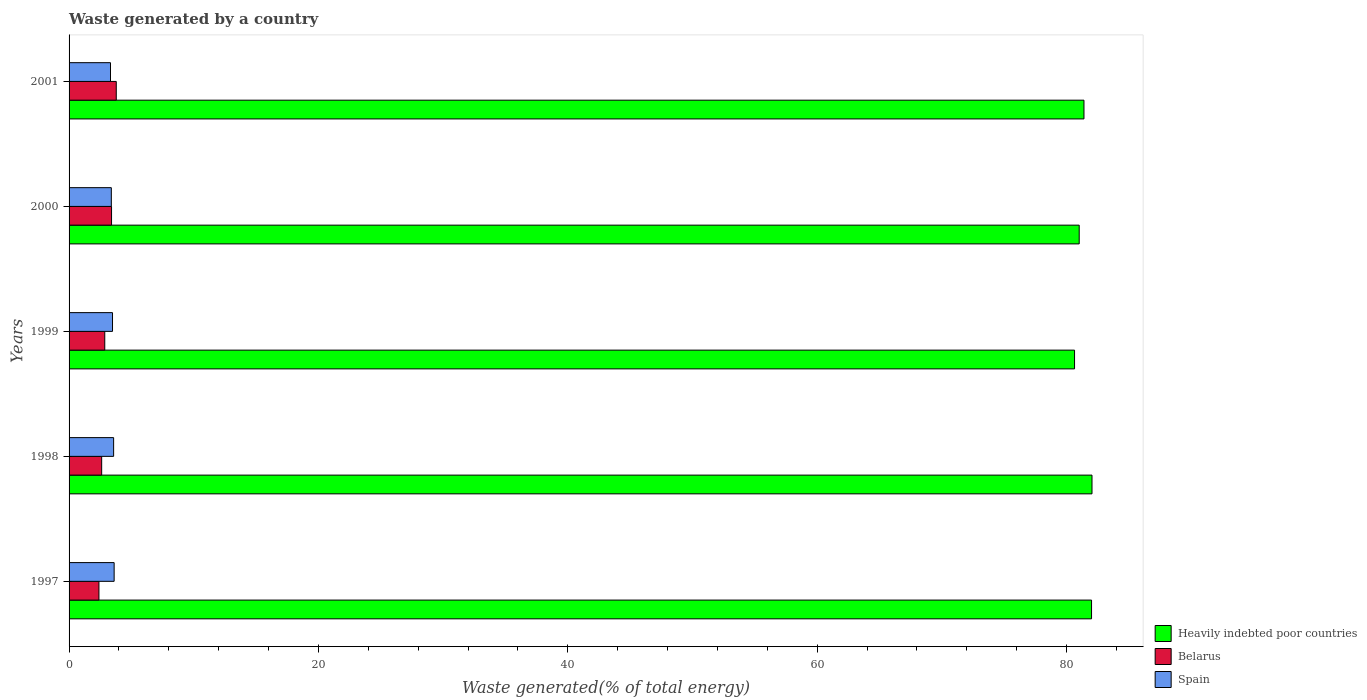How many different coloured bars are there?
Give a very brief answer. 3. Are the number of bars per tick equal to the number of legend labels?
Your answer should be compact. Yes. Are the number of bars on each tick of the Y-axis equal?
Your answer should be compact. Yes. How many bars are there on the 4th tick from the top?
Give a very brief answer. 3. What is the total waste generated in Spain in 1998?
Keep it short and to the point. 3.57. Across all years, what is the maximum total waste generated in Heavily indebted poor countries?
Give a very brief answer. 82.04. Across all years, what is the minimum total waste generated in Heavily indebted poor countries?
Provide a short and direct response. 80.64. In which year was the total waste generated in Belarus maximum?
Offer a terse response. 2001. What is the total total waste generated in Heavily indebted poor countries in the graph?
Offer a terse response. 407.1. What is the difference between the total waste generated in Spain in 1999 and that in 2001?
Keep it short and to the point. 0.16. What is the difference between the total waste generated in Heavily indebted poor countries in 1997 and the total waste generated in Spain in 1999?
Keep it short and to the point. 78.52. What is the average total waste generated in Spain per year?
Provide a short and direct response. 3.48. In the year 1998, what is the difference between the total waste generated in Heavily indebted poor countries and total waste generated in Spain?
Provide a short and direct response. 78.47. In how many years, is the total waste generated in Belarus greater than 32 %?
Offer a very short reply. 0. What is the ratio of the total waste generated in Belarus in 1997 to that in 1998?
Ensure brevity in your answer.  0.92. What is the difference between the highest and the second highest total waste generated in Belarus?
Offer a very short reply. 0.38. What is the difference between the highest and the lowest total waste generated in Belarus?
Provide a succinct answer. 1.39. In how many years, is the total waste generated in Belarus greater than the average total waste generated in Belarus taken over all years?
Provide a short and direct response. 2. What does the 1st bar from the top in 1997 represents?
Provide a succinct answer. Spain. What does the 1st bar from the bottom in 2001 represents?
Make the answer very short. Heavily indebted poor countries. How many bars are there?
Make the answer very short. 15. What is the difference between two consecutive major ticks on the X-axis?
Provide a short and direct response. 20. Does the graph contain any zero values?
Your answer should be very brief. No. How are the legend labels stacked?
Offer a very short reply. Vertical. What is the title of the graph?
Make the answer very short. Waste generated by a country. Does "World" appear as one of the legend labels in the graph?
Offer a very short reply. No. What is the label or title of the X-axis?
Offer a very short reply. Waste generated(% of total energy). What is the Waste generated(% of total energy) of Heavily indebted poor countries in 1997?
Your response must be concise. 82. What is the Waste generated(% of total energy) of Belarus in 1997?
Provide a succinct answer. 2.4. What is the Waste generated(% of total energy) in Spain in 1997?
Provide a succinct answer. 3.62. What is the Waste generated(% of total energy) in Heavily indebted poor countries in 1998?
Offer a very short reply. 82.04. What is the Waste generated(% of total energy) in Belarus in 1998?
Give a very brief answer. 2.61. What is the Waste generated(% of total energy) in Spain in 1998?
Offer a very short reply. 3.57. What is the Waste generated(% of total energy) in Heavily indebted poor countries in 1999?
Your answer should be compact. 80.64. What is the Waste generated(% of total energy) of Belarus in 1999?
Give a very brief answer. 2.86. What is the Waste generated(% of total energy) of Spain in 1999?
Keep it short and to the point. 3.48. What is the Waste generated(% of total energy) of Heavily indebted poor countries in 2000?
Make the answer very short. 81.02. What is the Waste generated(% of total energy) in Belarus in 2000?
Your answer should be very brief. 3.41. What is the Waste generated(% of total energy) of Spain in 2000?
Provide a short and direct response. 3.39. What is the Waste generated(% of total energy) in Heavily indebted poor countries in 2001?
Your answer should be compact. 81.4. What is the Waste generated(% of total energy) of Belarus in 2001?
Give a very brief answer. 3.79. What is the Waste generated(% of total energy) in Spain in 2001?
Your response must be concise. 3.32. Across all years, what is the maximum Waste generated(% of total energy) in Heavily indebted poor countries?
Offer a very short reply. 82.04. Across all years, what is the maximum Waste generated(% of total energy) in Belarus?
Give a very brief answer. 3.79. Across all years, what is the maximum Waste generated(% of total energy) in Spain?
Offer a terse response. 3.62. Across all years, what is the minimum Waste generated(% of total energy) of Heavily indebted poor countries?
Give a very brief answer. 80.64. Across all years, what is the minimum Waste generated(% of total energy) in Belarus?
Offer a terse response. 2.4. Across all years, what is the minimum Waste generated(% of total energy) of Spain?
Provide a short and direct response. 3.32. What is the total Waste generated(% of total energy) of Heavily indebted poor countries in the graph?
Offer a very short reply. 407.1. What is the total Waste generated(% of total energy) in Belarus in the graph?
Offer a terse response. 15.07. What is the total Waste generated(% of total energy) in Spain in the graph?
Make the answer very short. 17.39. What is the difference between the Waste generated(% of total energy) of Heavily indebted poor countries in 1997 and that in 1998?
Give a very brief answer. -0.04. What is the difference between the Waste generated(% of total energy) in Belarus in 1997 and that in 1998?
Keep it short and to the point. -0.22. What is the difference between the Waste generated(% of total energy) in Spain in 1997 and that in 1998?
Your answer should be very brief. 0.04. What is the difference between the Waste generated(% of total energy) in Heavily indebted poor countries in 1997 and that in 1999?
Give a very brief answer. 1.36. What is the difference between the Waste generated(% of total energy) in Belarus in 1997 and that in 1999?
Your answer should be compact. -0.47. What is the difference between the Waste generated(% of total energy) of Spain in 1997 and that in 1999?
Provide a succinct answer. 0.13. What is the difference between the Waste generated(% of total energy) of Heavily indebted poor countries in 1997 and that in 2000?
Your answer should be compact. 0.99. What is the difference between the Waste generated(% of total energy) of Belarus in 1997 and that in 2000?
Offer a very short reply. -1.01. What is the difference between the Waste generated(% of total energy) in Spain in 1997 and that in 2000?
Offer a terse response. 0.23. What is the difference between the Waste generated(% of total energy) of Heavily indebted poor countries in 1997 and that in 2001?
Your response must be concise. 0.61. What is the difference between the Waste generated(% of total energy) in Belarus in 1997 and that in 2001?
Your answer should be very brief. -1.39. What is the difference between the Waste generated(% of total energy) of Spain in 1997 and that in 2001?
Keep it short and to the point. 0.29. What is the difference between the Waste generated(% of total energy) in Heavily indebted poor countries in 1998 and that in 1999?
Give a very brief answer. 1.4. What is the difference between the Waste generated(% of total energy) of Belarus in 1998 and that in 1999?
Ensure brevity in your answer.  -0.25. What is the difference between the Waste generated(% of total energy) of Spain in 1998 and that in 1999?
Give a very brief answer. 0.09. What is the difference between the Waste generated(% of total energy) of Heavily indebted poor countries in 1998 and that in 2000?
Give a very brief answer. 1.03. What is the difference between the Waste generated(% of total energy) of Belarus in 1998 and that in 2000?
Keep it short and to the point. -0.79. What is the difference between the Waste generated(% of total energy) of Spain in 1998 and that in 2000?
Offer a terse response. 0.18. What is the difference between the Waste generated(% of total energy) in Heavily indebted poor countries in 1998 and that in 2001?
Offer a very short reply. 0.64. What is the difference between the Waste generated(% of total energy) of Belarus in 1998 and that in 2001?
Your response must be concise. -1.17. What is the difference between the Waste generated(% of total energy) in Spain in 1998 and that in 2001?
Your answer should be very brief. 0.25. What is the difference between the Waste generated(% of total energy) of Heavily indebted poor countries in 1999 and that in 2000?
Provide a succinct answer. -0.37. What is the difference between the Waste generated(% of total energy) of Belarus in 1999 and that in 2000?
Keep it short and to the point. -0.54. What is the difference between the Waste generated(% of total energy) in Spain in 1999 and that in 2000?
Provide a short and direct response. 0.1. What is the difference between the Waste generated(% of total energy) in Heavily indebted poor countries in 1999 and that in 2001?
Offer a very short reply. -0.76. What is the difference between the Waste generated(% of total energy) in Belarus in 1999 and that in 2001?
Offer a very short reply. -0.92. What is the difference between the Waste generated(% of total energy) of Spain in 1999 and that in 2001?
Make the answer very short. 0.16. What is the difference between the Waste generated(% of total energy) of Heavily indebted poor countries in 2000 and that in 2001?
Keep it short and to the point. -0.38. What is the difference between the Waste generated(% of total energy) in Belarus in 2000 and that in 2001?
Provide a succinct answer. -0.38. What is the difference between the Waste generated(% of total energy) in Spain in 2000 and that in 2001?
Ensure brevity in your answer.  0.07. What is the difference between the Waste generated(% of total energy) of Heavily indebted poor countries in 1997 and the Waste generated(% of total energy) of Belarus in 1998?
Offer a terse response. 79.39. What is the difference between the Waste generated(% of total energy) in Heavily indebted poor countries in 1997 and the Waste generated(% of total energy) in Spain in 1998?
Offer a very short reply. 78.43. What is the difference between the Waste generated(% of total energy) of Belarus in 1997 and the Waste generated(% of total energy) of Spain in 1998?
Give a very brief answer. -1.18. What is the difference between the Waste generated(% of total energy) of Heavily indebted poor countries in 1997 and the Waste generated(% of total energy) of Belarus in 1999?
Provide a succinct answer. 79.14. What is the difference between the Waste generated(% of total energy) in Heavily indebted poor countries in 1997 and the Waste generated(% of total energy) in Spain in 1999?
Provide a succinct answer. 78.52. What is the difference between the Waste generated(% of total energy) of Belarus in 1997 and the Waste generated(% of total energy) of Spain in 1999?
Your response must be concise. -1.09. What is the difference between the Waste generated(% of total energy) of Heavily indebted poor countries in 1997 and the Waste generated(% of total energy) of Belarus in 2000?
Offer a terse response. 78.6. What is the difference between the Waste generated(% of total energy) of Heavily indebted poor countries in 1997 and the Waste generated(% of total energy) of Spain in 2000?
Give a very brief answer. 78.62. What is the difference between the Waste generated(% of total energy) of Belarus in 1997 and the Waste generated(% of total energy) of Spain in 2000?
Provide a short and direct response. -0.99. What is the difference between the Waste generated(% of total energy) of Heavily indebted poor countries in 1997 and the Waste generated(% of total energy) of Belarus in 2001?
Provide a short and direct response. 78.22. What is the difference between the Waste generated(% of total energy) in Heavily indebted poor countries in 1997 and the Waste generated(% of total energy) in Spain in 2001?
Your answer should be very brief. 78.68. What is the difference between the Waste generated(% of total energy) of Belarus in 1997 and the Waste generated(% of total energy) of Spain in 2001?
Your answer should be compact. -0.93. What is the difference between the Waste generated(% of total energy) of Heavily indebted poor countries in 1998 and the Waste generated(% of total energy) of Belarus in 1999?
Your response must be concise. 79.18. What is the difference between the Waste generated(% of total energy) in Heavily indebted poor countries in 1998 and the Waste generated(% of total energy) in Spain in 1999?
Provide a succinct answer. 78.56. What is the difference between the Waste generated(% of total energy) in Belarus in 1998 and the Waste generated(% of total energy) in Spain in 1999?
Provide a succinct answer. -0.87. What is the difference between the Waste generated(% of total energy) in Heavily indebted poor countries in 1998 and the Waste generated(% of total energy) in Belarus in 2000?
Offer a very short reply. 78.63. What is the difference between the Waste generated(% of total energy) in Heavily indebted poor countries in 1998 and the Waste generated(% of total energy) in Spain in 2000?
Offer a terse response. 78.65. What is the difference between the Waste generated(% of total energy) of Belarus in 1998 and the Waste generated(% of total energy) of Spain in 2000?
Your answer should be very brief. -0.77. What is the difference between the Waste generated(% of total energy) in Heavily indebted poor countries in 1998 and the Waste generated(% of total energy) in Belarus in 2001?
Provide a succinct answer. 78.26. What is the difference between the Waste generated(% of total energy) of Heavily indebted poor countries in 1998 and the Waste generated(% of total energy) of Spain in 2001?
Give a very brief answer. 78.72. What is the difference between the Waste generated(% of total energy) of Belarus in 1998 and the Waste generated(% of total energy) of Spain in 2001?
Provide a succinct answer. -0.71. What is the difference between the Waste generated(% of total energy) in Heavily indebted poor countries in 1999 and the Waste generated(% of total energy) in Belarus in 2000?
Offer a very short reply. 77.23. What is the difference between the Waste generated(% of total energy) in Heavily indebted poor countries in 1999 and the Waste generated(% of total energy) in Spain in 2000?
Make the answer very short. 77.25. What is the difference between the Waste generated(% of total energy) of Belarus in 1999 and the Waste generated(% of total energy) of Spain in 2000?
Provide a short and direct response. -0.53. What is the difference between the Waste generated(% of total energy) in Heavily indebted poor countries in 1999 and the Waste generated(% of total energy) in Belarus in 2001?
Provide a succinct answer. 76.86. What is the difference between the Waste generated(% of total energy) in Heavily indebted poor countries in 1999 and the Waste generated(% of total energy) in Spain in 2001?
Offer a very short reply. 77.32. What is the difference between the Waste generated(% of total energy) in Belarus in 1999 and the Waste generated(% of total energy) in Spain in 2001?
Make the answer very short. -0.46. What is the difference between the Waste generated(% of total energy) in Heavily indebted poor countries in 2000 and the Waste generated(% of total energy) in Belarus in 2001?
Make the answer very short. 77.23. What is the difference between the Waste generated(% of total energy) in Heavily indebted poor countries in 2000 and the Waste generated(% of total energy) in Spain in 2001?
Your answer should be compact. 77.69. What is the difference between the Waste generated(% of total energy) of Belarus in 2000 and the Waste generated(% of total energy) of Spain in 2001?
Provide a short and direct response. 0.08. What is the average Waste generated(% of total energy) in Heavily indebted poor countries per year?
Give a very brief answer. 81.42. What is the average Waste generated(% of total energy) of Belarus per year?
Keep it short and to the point. 3.01. What is the average Waste generated(% of total energy) of Spain per year?
Give a very brief answer. 3.48. In the year 1997, what is the difference between the Waste generated(% of total energy) of Heavily indebted poor countries and Waste generated(% of total energy) of Belarus?
Your answer should be very brief. 79.61. In the year 1997, what is the difference between the Waste generated(% of total energy) of Heavily indebted poor countries and Waste generated(% of total energy) of Spain?
Provide a short and direct response. 78.39. In the year 1997, what is the difference between the Waste generated(% of total energy) in Belarus and Waste generated(% of total energy) in Spain?
Offer a very short reply. -1.22. In the year 1998, what is the difference between the Waste generated(% of total energy) of Heavily indebted poor countries and Waste generated(% of total energy) of Belarus?
Offer a terse response. 79.43. In the year 1998, what is the difference between the Waste generated(% of total energy) of Heavily indebted poor countries and Waste generated(% of total energy) of Spain?
Offer a terse response. 78.47. In the year 1998, what is the difference between the Waste generated(% of total energy) in Belarus and Waste generated(% of total energy) in Spain?
Ensure brevity in your answer.  -0.96. In the year 1999, what is the difference between the Waste generated(% of total energy) in Heavily indebted poor countries and Waste generated(% of total energy) in Belarus?
Provide a succinct answer. 77.78. In the year 1999, what is the difference between the Waste generated(% of total energy) in Heavily indebted poor countries and Waste generated(% of total energy) in Spain?
Give a very brief answer. 77.16. In the year 1999, what is the difference between the Waste generated(% of total energy) in Belarus and Waste generated(% of total energy) in Spain?
Your answer should be compact. -0.62. In the year 2000, what is the difference between the Waste generated(% of total energy) of Heavily indebted poor countries and Waste generated(% of total energy) of Belarus?
Offer a terse response. 77.61. In the year 2000, what is the difference between the Waste generated(% of total energy) of Heavily indebted poor countries and Waste generated(% of total energy) of Spain?
Offer a very short reply. 77.63. In the year 2000, what is the difference between the Waste generated(% of total energy) in Belarus and Waste generated(% of total energy) in Spain?
Your response must be concise. 0.02. In the year 2001, what is the difference between the Waste generated(% of total energy) in Heavily indebted poor countries and Waste generated(% of total energy) in Belarus?
Provide a short and direct response. 77.61. In the year 2001, what is the difference between the Waste generated(% of total energy) of Heavily indebted poor countries and Waste generated(% of total energy) of Spain?
Keep it short and to the point. 78.07. In the year 2001, what is the difference between the Waste generated(% of total energy) in Belarus and Waste generated(% of total energy) in Spain?
Provide a succinct answer. 0.46. What is the ratio of the Waste generated(% of total energy) of Belarus in 1997 to that in 1998?
Provide a short and direct response. 0.92. What is the ratio of the Waste generated(% of total energy) in Spain in 1997 to that in 1998?
Offer a very short reply. 1.01. What is the ratio of the Waste generated(% of total energy) of Heavily indebted poor countries in 1997 to that in 1999?
Ensure brevity in your answer.  1.02. What is the ratio of the Waste generated(% of total energy) in Belarus in 1997 to that in 1999?
Give a very brief answer. 0.84. What is the ratio of the Waste generated(% of total energy) in Spain in 1997 to that in 1999?
Make the answer very short. 1.04. What is the ratio of the Waste generated(% of total energy) in Heavily indebted poor countries in 1997 to that in 2000?
Your response must be concise. 1.01. What is the ratio of the Waste generated(% of total energy) in Belarus in 1997 to that in 2000?
Your answer should be compact. 0.7. What is the ratio of the Waste generated(% of total energy) of Spain in 1997 to that in 2000?
Ensure brevity in your answer.  1.07. What is the ratio of the Waste generated(% of total energy) of Heavily indebted poor countries in 1997 to that in 2001?
Provide a succinct answer. 1.01. What is the ratio of the Waste generated(% of total energy) of Belarus in 1997 to that in 2001?
Provide a succinct answer. 0.63. What is the ratio of the Waste generated(% of total energy) in Spain in 1997 to that in 2001?
Provide a succinct answer. 1.09. What is the ratio of the Waste generated(% of total energy) of Heavily indebted poor countries in 1998 to that in 1999?
Your response must be concise. 1.02. What is the ratio of the Waste generated(% of total energy) of Belarus in 1998 to that in 1999?
Your answer should be very brief. 0.91. What is the ratio of the Waste generated(% of total energy) of Spain in 1998 to that in 1999?
Give a very brief answer. 1.03. What is the ratio of the Waste generated(% of total energy) of Heavily indebted poor countries in 1998 to that in 2000?
Offer a terse response. 1.01. What is the ratio of the Waste generated(% of total energy) of Belarus in 1998 to that in 2000?
Your response must be concise. 0.77. What is the ratio of the Waste generated(% of total energy) in Spain in 1998 to that in 2000?
Offer a very short reply. 1.05. What is the ratio of the Waste generated(% of total energy) in Heavily indebted poor countries in 1998 to that in 2001?
Make the answer very short. 1.01. What is the ratio of the Waste generated(% of total energy) of Belarus in 1998 to that in 2001?
Provide a short and direct response. 0.69. What is the ratio of the Waste generated(% of total energy) of Spain in 1998 to that in 2001?
Make the answer very short. 1.08. What is the ratio of the Waste generated(% of total energy) in Belarus in 1999 to that in 2000?
Your answer should be compact. 0.84. What is the ratio of the Waste generated(% of total energy) of Spain in 1999 to that in 2000?
Provide a short and direct response. 1.03. What is the ratio of the Waste generated(% of total energy) of Heavily indebted poor countries in 1999 to that in 2001?
Provide a succinct answer. 0.99. What is the ratio of the Waste generated(% of total energy) in Belarus in 1999 to that in 2001?
Make the answer very short. 0.76. What is the ratio of the Waste generated(% of total energy) of Spain in 1999 to that in 2001?
Ensure brevity in your answer.  1.05. What is the ratio of the Waste generated(% of total energy) in Belarus in 2000 to that in 2001?
Your answer should be very brief. 0.9. What is the ratio of the Waste generated(% of total energy) of Spain in 2000 to that in 2001?
Offer a terse response. 1.02. What is the difference between the highest and the second highest Waste generated(% of total energy) in Heavily indebted poor countries?
Keep it short and to the point. 0.04. What is the difference between the highest and the second highest Waste generated(% of total energy) in Belarus?
Your response must be concise. 0.38. What is the difference between the highest and the second highest Waste generated(% of total energy) in Spain?
Make the answer very short. 0.04. What is the difference between the highest and the lowest Waste generated(% of total energy) of Heavily indebted poor countries?
Offer a very short reply. 1.4. What is the difference between the highest and the lowest Waste generated(% of total energy) of Belarus?
Your response must be concise. 1.39. What is the difference between the highest and the lowest Waste generated(% of total energy) in Spain?
Your response must be concise. 0.29. 